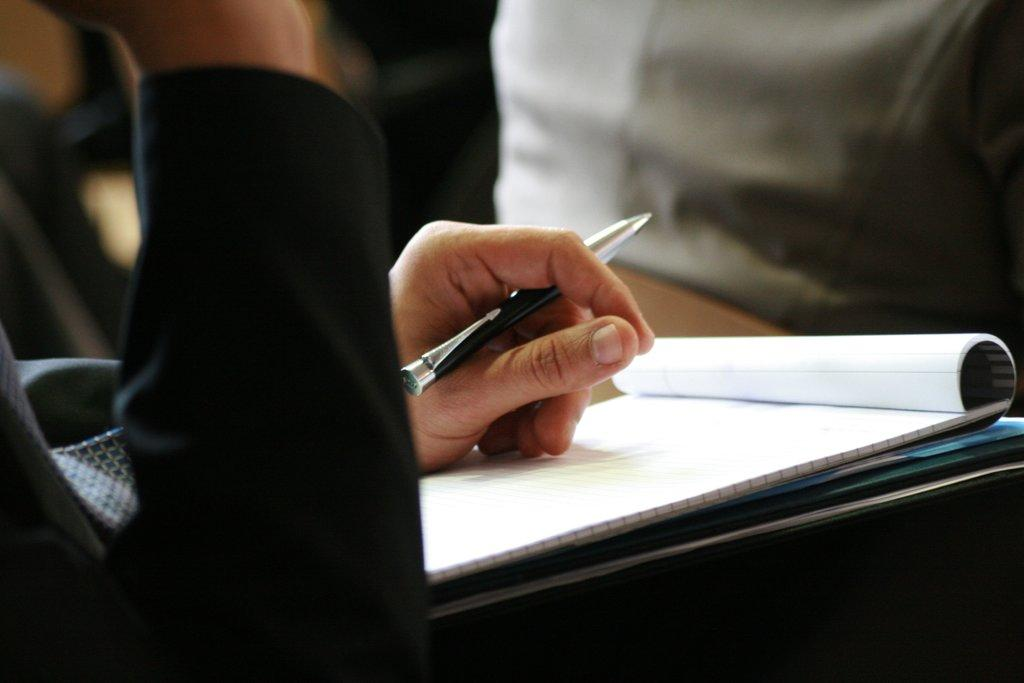What can be seen in the image? There is a hand in the image. What is the hand holding? The hand is holding a pen. What else is present in the image? There is a book in the image. How many kittens are playing with the rabbits in the image? There are no kittens or rabbits present in the image; it only features a hand holding a pen and a book. 